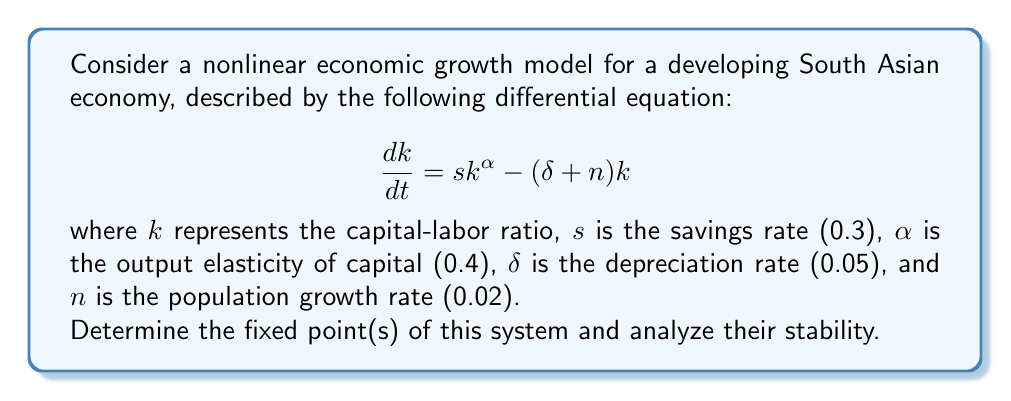Help me with this question. 1. To find the fixed points, we set $\frac{dk}{dt} = 0$:

   $$sk^{\alpha} - (\delta + n)k = 0$$

2. Substituting the given values:

   $$0.3k^{0.4} - (0.05 + 0.02)k = 0$$
   $$0.3k^{0.4} - 0.07k = 0$$

3. Factor out $k$:

   $$k(0.3k^{-0.6} - 0.07) = 0$$

4. Solve for $k$:
   
   $k = 0$ or $0.3k^{-0.6} = 0.07$
   
   For the non-zero solution:
   $$k^{-0.6} = \frac{0.07}{0.3}$$
   $$k^{0.6} = \frac{0.3}{0.07}$$
   $$k = (\frac{0.3}{0.07})^{\frac{5}{3}} \approx 36.75$$

5. To analyze stability, we find the derivative of $\frac{dk}{dt}$ with respect to $k$:

   $$\frac{d}{dk}(\frac{dk}{dt}) = \alpha sk^{\alpha-1} - (\delta + n)$$

6. Evaluate this at each fixed point:

   At $k = 0$: $\lim_{k \to 0} (0.4 \cdot 0.3 \cdot k^{-0.6} - 0.07) = \infty$
   
   At $k \approx 36.75$: $0.4 \cdot 0.3 \cdot 36.75^{-0.6} - 0.07 = 0$

7. Interpret the results:
   - $k = 0$ is an unstable fixed point (positive derivative)
   - $k \approx 36.75$ is a stable fixed point (zero derivative, changes sign from positive to negative)
Answer: Fixed points: $k = 0$ (unstable) and $k \approx 36.75$ (stable) 